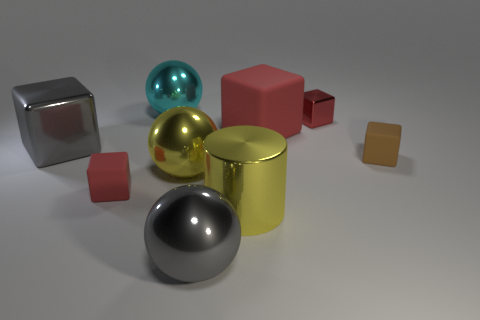The tiny object that is the same material as the large cyan object is what shape?
Make the answer very short. Cube. Is there anything else of the same color as the big cylinder?
Offer a terse response. Yes. There is a gray cube to the left of the small brown rubber block; what is its material?
Make the answer very short. Metal. Do the gray metallic cube and the brown matte object have the same size?
Give a very brief answer. No. What number of other objects are the same size as the red metal cube?
Your answer should be very brief. 2. Is the color of the large rubber block the same as the tiny shiny cube?
Make the answer very short. Yes. What is the shape of the small rubber thing on the right side of the gray shiny thing on the right side of the tiny rubber block left of the large cyan metal sphere?
Keep it short and to the point. Cube. What number of objects are red matte objects on the right side of the large cylinder or tiny cubes that are in front of the large matte object?
Ensure brevity in your answer.  3. What is the size of the yellow shiny object to the right of the gray object on the right side of the cyan thing?
Give a very brief answer. Large. There is a small object that is left of the small red shiny thing; does it have the same color as the big matte cube?
Make the answer very short. Yes. 